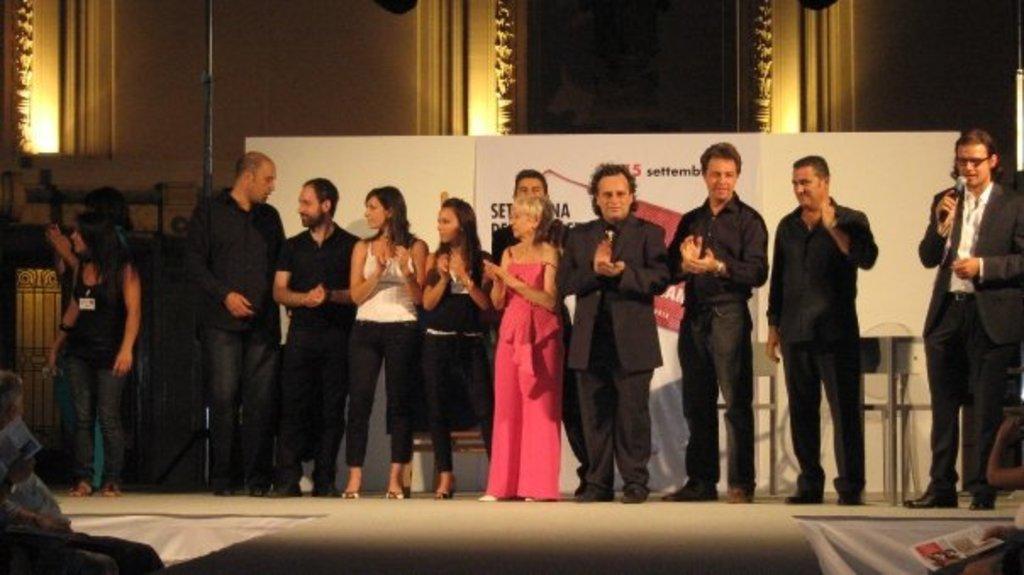Could you give a brief overview of what you see in this image? In this image we can see there are many people standing on the stage and a person on the right side holding a mike and speaking about something. 